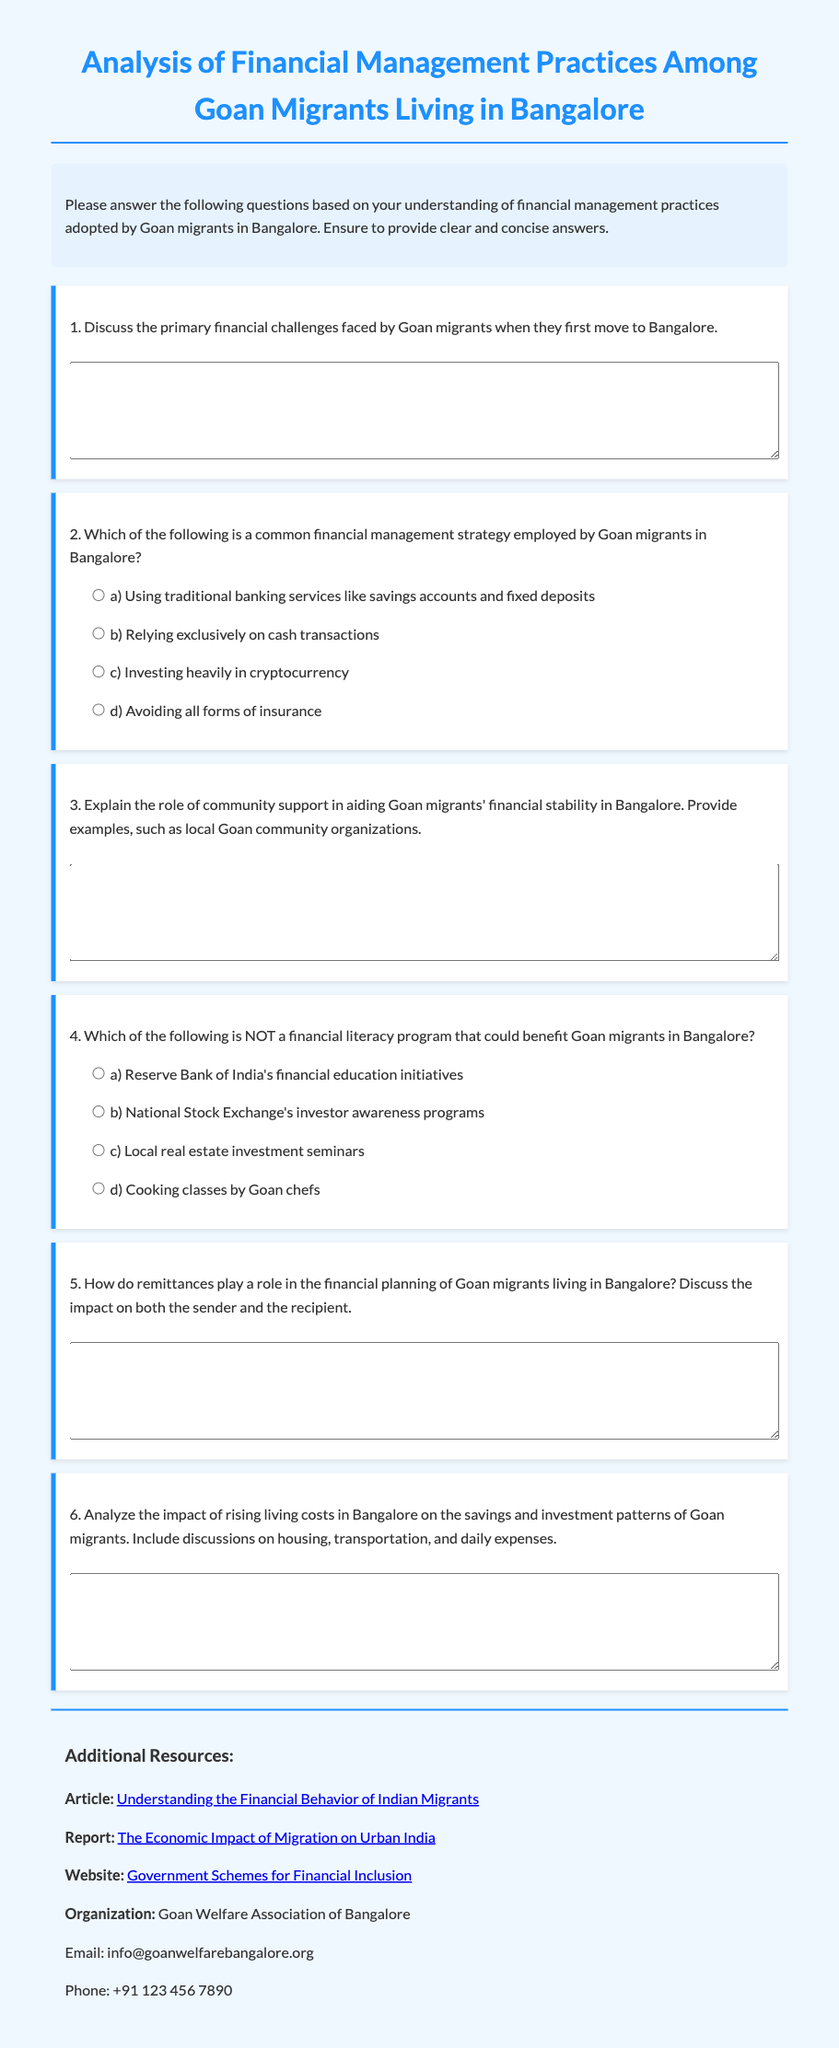What is the title of the document? The title of the document is prominently displayed at the top of the page.
Answer: Analysis of Financial Management Practices Among Goan Migrants Living in Bangalore What is one primary financial challenge faced by Goan migrants in Bangalore? This information can be derived from the first question in the exam, which prompts discussion on financial challenges.
Answer: (Answers may vary) Name a common financial management strategy employed by Goan migrants. This can be found in question two, which lists options for financial management strategies.
Answer: a) Using traditional banking services like savings accounts and fixed deposits What is NOT a financial literacy program that could benefit Goan migrants? The fourth question specifically asks for an option that is NOT a financial literacy program.
Answer: d) Cooking classes by Goan chefs Who can be contacted for assistance from the Goan Welfare Association of Bangalore? The document provides contact details for the Goan Welfare Association of Bangalore.
Answer: info@goanwelfarebangalore.org How many questions are in the exam? The document contains a total of six questions, as indicated by the numbered list.
Answer: 6 What impact do remittances have on financial planning? This is discussed in question five, which requires an explanation of the role of remittances.
Answer: (Answers may vary) Which organization is mentioned as a resource for Goan migrants? The resources section lists organizations that can assist Goan migrants, specifically highlighting one.
Answer: Goan Welfare Association of Bangalore 